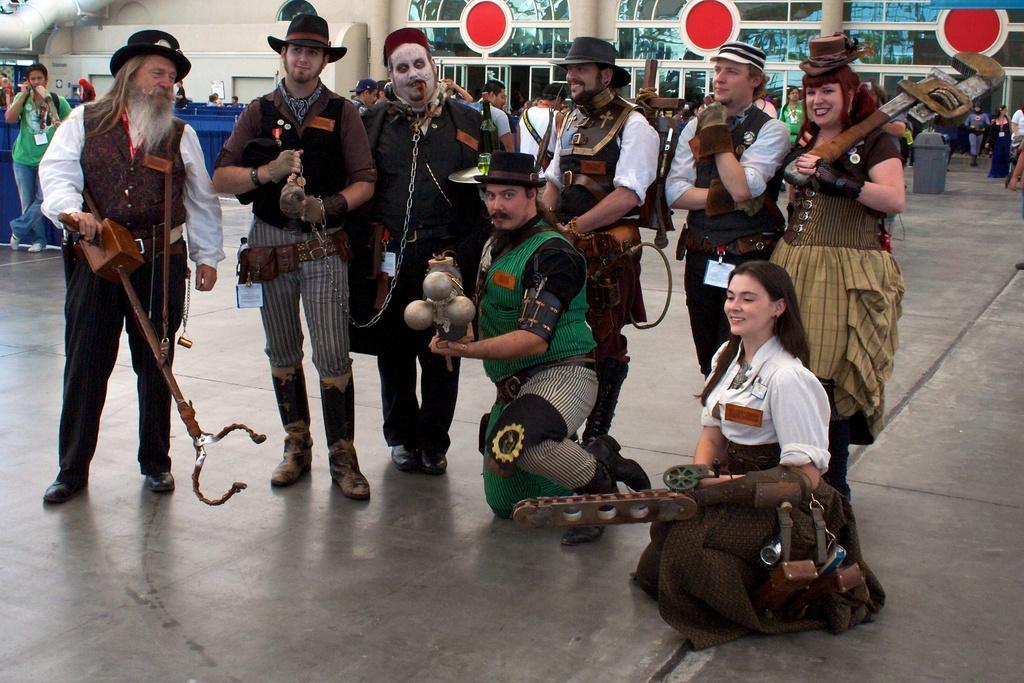Describe this image in one or two sentences. In this image we can see few people wearing some costumes. Some are wearing caps. And some are holding something in the hand. In the back there are many people. Also there is a wall. On the wall there is a red color round things. And there is a waste bin. In the left top corner there is a pipe. 